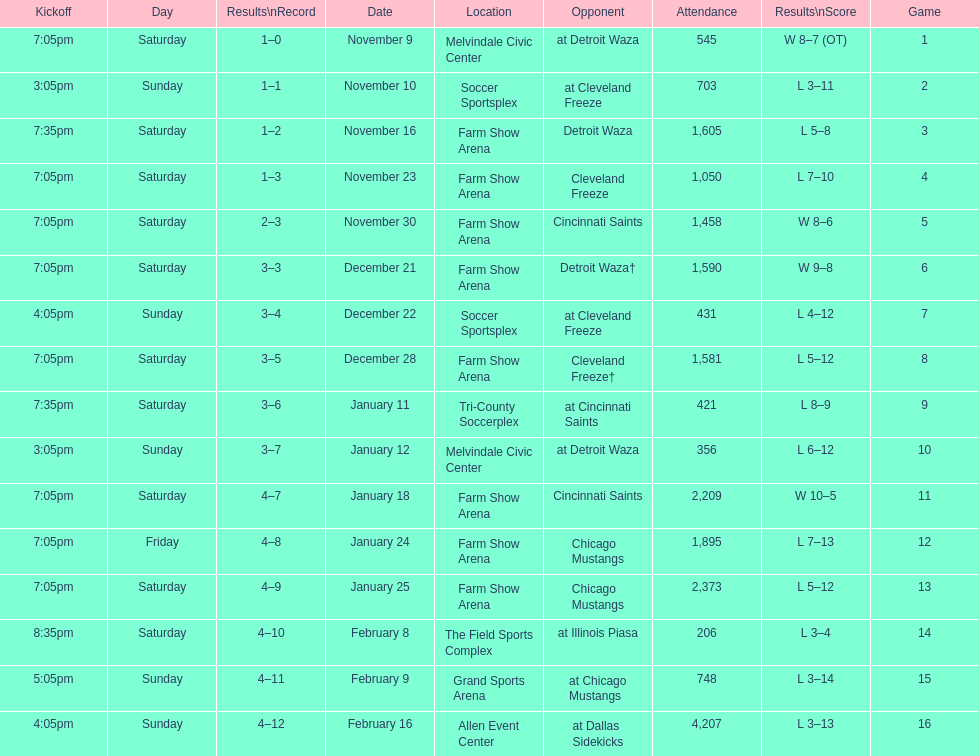What was the location before tri-county soccerplex? Farm Show Arena. 